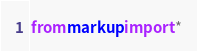<code> <loc_0><loc_0><loc_500><loc_500><_Python_>from markup import *
</code> 